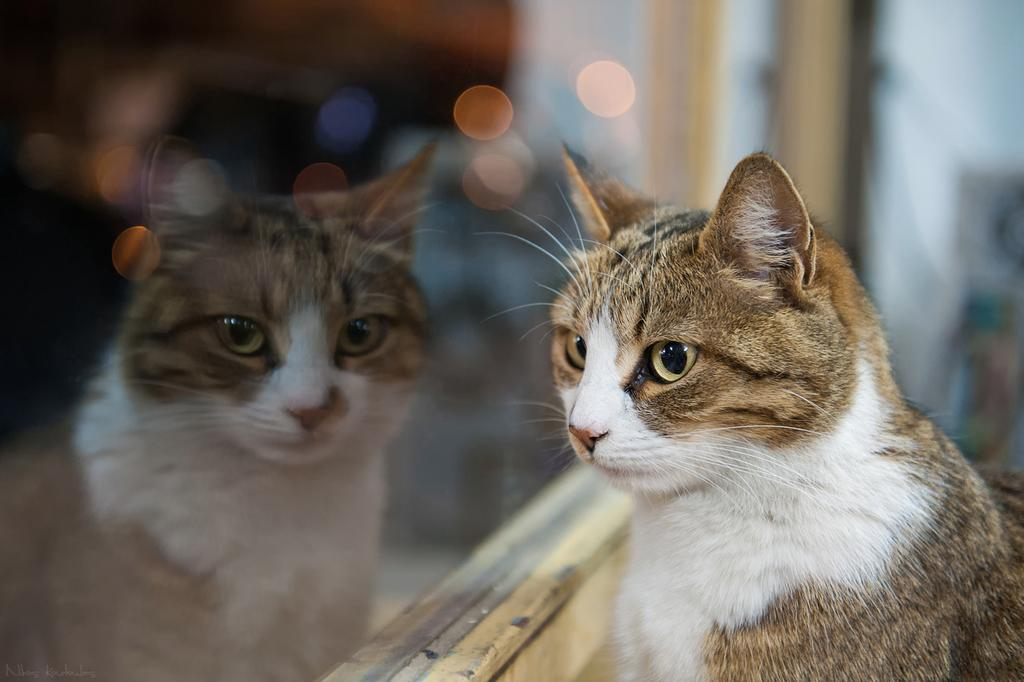What type of animal is present in the image? There is a cat in the image. Can you describe the appearance of the cat in the image? The cat's reflection is visible in the image. What else can be seen in the image besides the cat? There are lights in the image. What type of wave can be seen in the image? There is no wave present in the image; it features a cat and its reflection, as well as lights. How does the cow interact with the cat in the image? There is no cow present in the image; it only features a cat and its reflection, along with lights. 